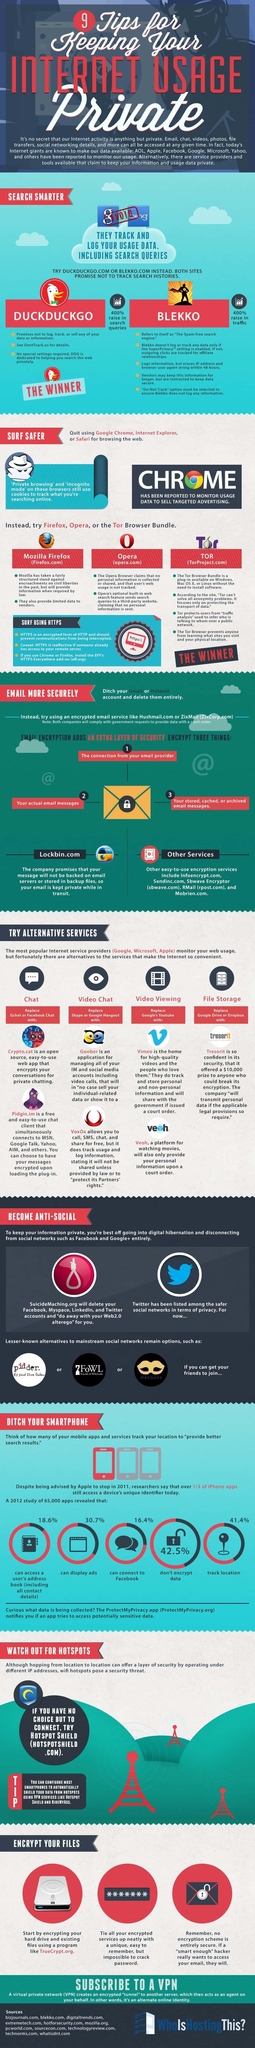Identify some key points in this picture. It is possible to replace Gchat or Facebook Chat with either Cryto.cat or Pidgin.im. Mozilla Firefox is a search engine that can be used to surf the internet in a safer manner, as compared to Safari and Google Chrome. Google and Bing are two search engines that track the search histories of their users. The best browser bundle among Opera, TOR, and Mozilla Firefox is TOR. Tresorit is considered to provide better security for storing files than Google Drive and Dropbox. 